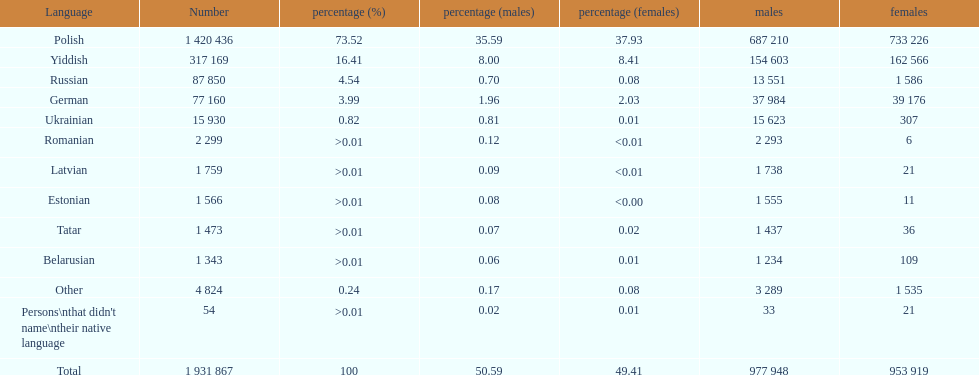Which language had the least female speakers? Romanian. 